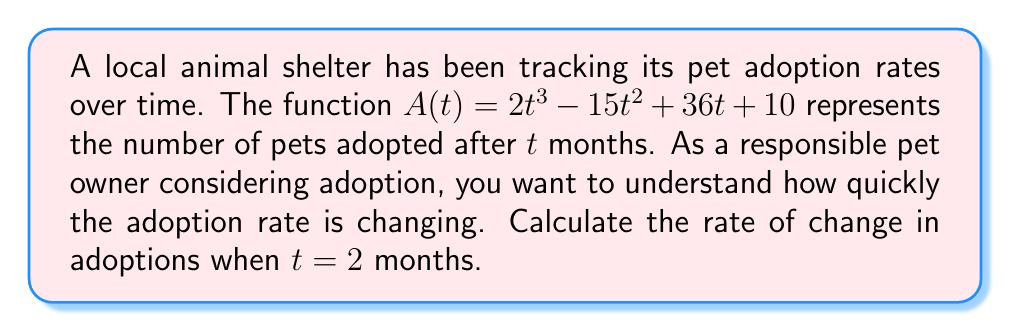Give your solution to this math problem. To find the rate of change in adoptions at $t = 2$ months, we need to calculate the derivative of $A(t)$ and evaluate it at $t = 2$.

Step 1: Find the derivative of $A(t)$
$$A(t) = 2t^3 - 15t^2 + 36t + 10$$
$$A'(t) = 6t^2 - 30t + 36$$

Step 2: Evaluate $A'(t)$ at $t = 2$
$$A'(2) = 6(2)^2 - 30(2) + 36$$
$$A'(2) = 6(4) - 60 + 36$$
$$A'(2) = 24 - 60 + 36$$
$$A'(2) = 0$$

The rate of change in adoptions at $t = 2$ months is 0 pets per month. This means that at exactly 2 months, the adoption rate has momentarily stabilized, neither increasing nor decreasing.
Answer: 0 pets/month 